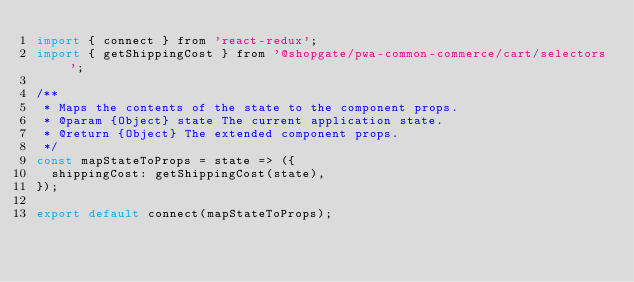Convert code to text. <code><loc_0><loc_0><loc_500><loc_500><_JavaScript_>import { connect } from 'react-redux';
import { getShippingCost } from '@shopgate/pwa-common-commerce/cart/selectors';

/**
 * Maps the contents of the state to the component props.
 * @param {Object} state The current application state.
 * @return {Object} The extended component props.
 */
const mapStateToProps = state => ({
  shippingCost: getShippingCost(state),
});

export default connect(mapStateToProps);
</code> 